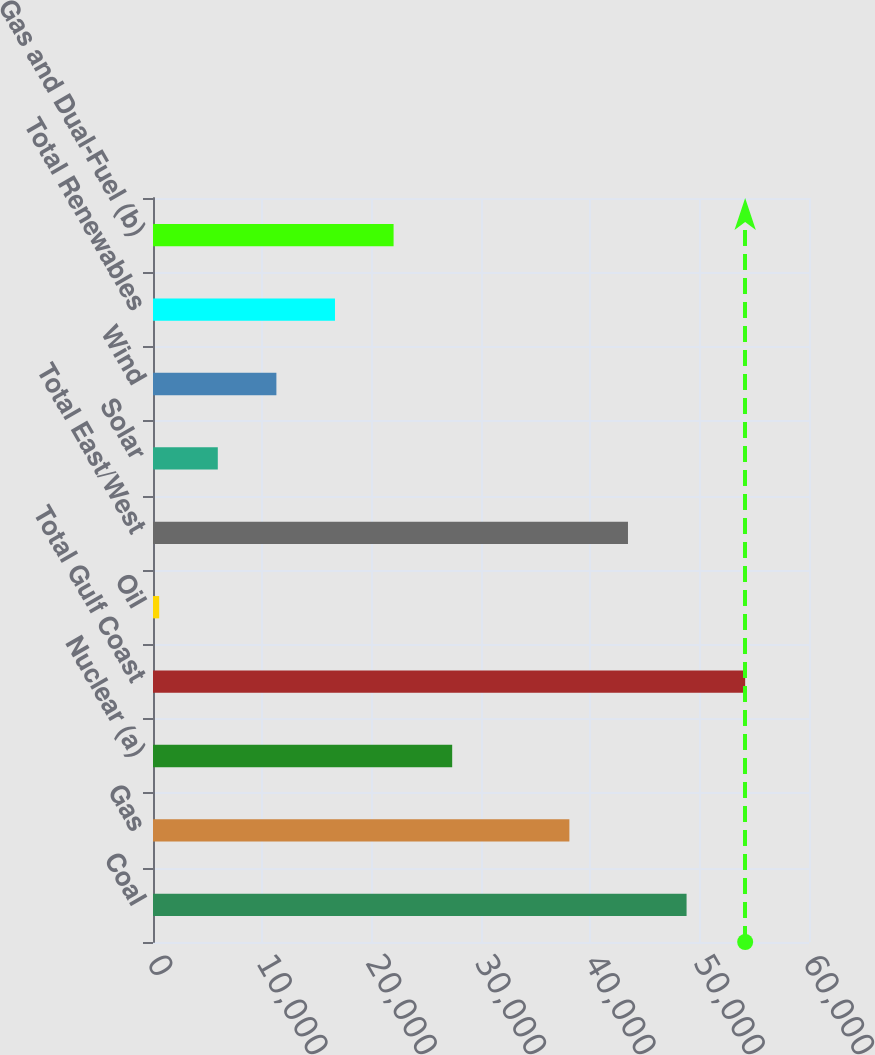<chart> <loc_0><loc_0><loc_500><loc_500><bar_chart><fcel>Coal<fcel>Gas<fcel>Nuclear (a)<fcel>Total Gulf Coast<fcel>Oil<fcel>Total East/West<fcel>Solar<fcel>Wind<fcel>Total Renewables<fcel>Gas and Dual-Fuel (b)<nl><fcel>48802.5<fcel>38083.5<fcel>27364.5<fcel>54162<fcel>567<fcel>43443<fcel>5926.5<fcel>11286<fcel>16645.5<fcel>22005<nl></chart> 